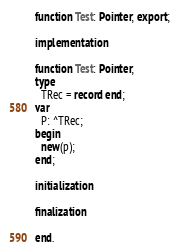<code> <loc_0><loc_0><loc_500><loc_500><_Pascal_>function Test: Pointer; export;

implementation

function Test: Pointer;
type
  TRec = record end;
var
  P: ^TRec;
begin
  new(p);
end;

initialization

finalization

end.</code> 